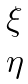<formula> <loc_0><loc_0><loc_500><loc_500>\begin{matrix} \xi \\ \eta \end{matrix}</formula> 